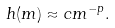Convert formula to latex. <formula><loc_0><loc_0><loc_500><loc_500>h ( m ) \approx c m ^ { - p } .</formula> 